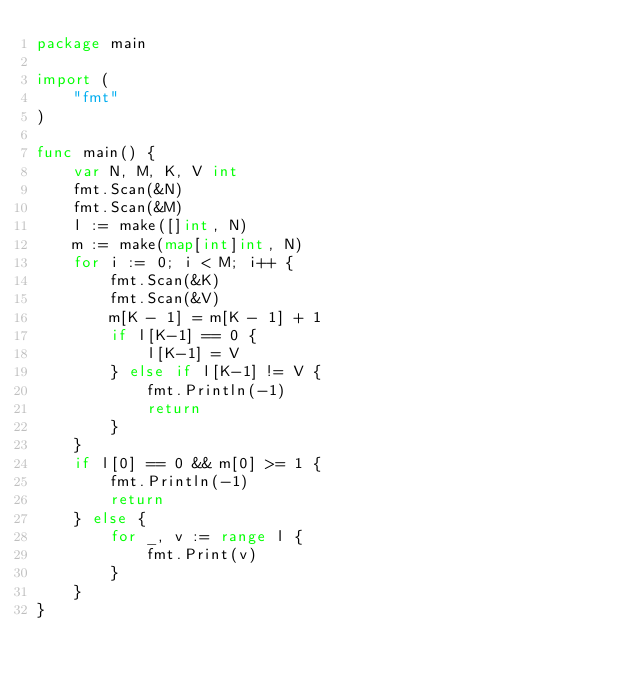<code> <loc_0><loc_0><loc_500><loc_500><_Go_>package main
 
import (
	"fmt"
)
 
func main() {
	var N, M, K, V int
	fmt.Scan(&N)
	fmt.Scan(&M)
	l := make([]int, N)
	m := make(map[int]int, N)
	for i := 0; i < M; i++ {
	    fmt.Scan(&K)
		fmt.Scan(&V)
		m[K - 1] = m[K - 1] + 1
		if l[K-1] == 0 {
			l[K-1] = V
		} else if l[K-1] != V {
			fmt.Println(-1)
			return
		}
	}
	if l[0] == 0 && m[0] >= 1 {
		fmt.Println(-1)
		return
	} else {
		for _, v := range l {
			fmt.Print(v)
		}
	}
}
</code> 